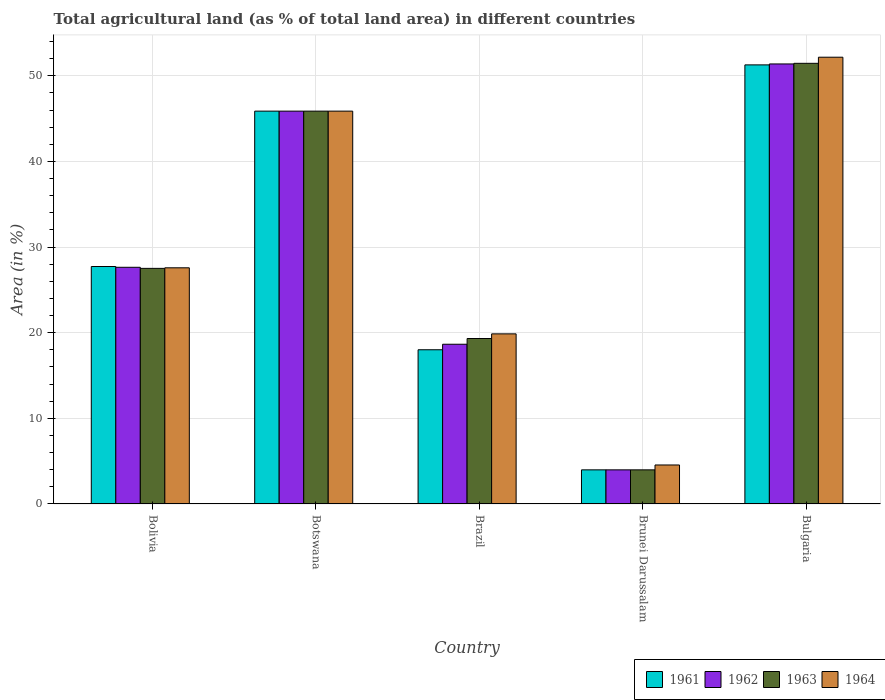How many bars are there on the 2nd tick from the left?
Your answer should be compact. 4. How many bars are there on the 3rd tick from the right?
Your answer should be very brief. 4. What is the label of the 5th group of bars from the left?
Your answer should be compact. Bulgaria. In how many cases, is the number of bars for a given country not equal to the number of legend labels?
Your answer should be compact. 0. What is the percentage of agricultural land in 1963 in Brazil?
Make the answer very short. 19.32. Across all countries, what is the maximum percentage of agricultural land in 1964?
Your response must be concise. 52.17. Across all countries, what is the minimum percentage of agricultural land in 1961?
Ensure brevity in your answer.  3.98. In which country was the percentage of agricultural land in 1961 maximum?
Ensure brevity in your answer.  Bulgaria. In which country was the percentage of agricultural land in 1962 minimum?
Ensure brevity in your answer.  Brunei Darussalam. What is the total percentage of agricultural land in 1961 in the graph?
Make the answer very short. 146.88. What is the difference between the percentage of agricultural land in 1961 in Bolivia and that in Brunei Darussalam?
Provide a short and direct response. 23.75. What is the difference between the percentage of agricultural land in 1962 in Botswana and the percentage of agricultural land in 1963 in Brazil?
Offer a terse response. 26.55. What is the average percentage of agricultural land in 1961 per country?
Your response must be concise. 29.38. What is the difference between the percentage of agricultural land of/in 1962 and percentage of agricultural land of/in 1964 in Brunei Darussalam?
Make the answer very short. -0.57. In how many countries, is the percentage of agricultural land in 1963 greater than 8 %?
Offer a very short reply. 4. What is the ratio of the percentage of agricultural land in 1961 in Botswana to that in Bulgaria?
Make the answer very short. 0.89. What is the difference between the highest and the second highest percentage of agricultural land in 1964?
Give a very brief answer. -24.59. What is the difference between the highest and the lowest percentage of agricultural land in 1964?
Your response must be concise. 47.62. In how many countries, is the percentage of agricultural land in 1962 greater than the average percentage of agricultural land in 1962 taken over all countries?
Your answer should be very brief. 2. What does the 1st bar from the right in Botswana represents?
Your answer should be compact. 1964. How many bars are there?
Give a very brief answer. 20. Are all the bars in the graph horizontal?
Keep it short and to the point. No. Does the graph contain any zero values?
Provide a succinct answer. No. Does the graph contain grids?
Offer a very short reply. Yes. What is the title of the graph?
Keep it short and to the point. Total agricultural land (as % of total land area) in different countries. Does "1984" appear as one of the legend labels in the graph?
Offer a terse response. No. What is the label or title of the X-axis?
Offer a very short reply. Country. What is the label or title of the Y-axis?
Your answer should be compact. Area (in %). What is the Area (in %) in 1961 in Bolivia?
Give a very brief answer. 27.73. What is the Area (in %) of 1962 in Bolivia?
Offer a terse response. 27.64. What is the Area (in %) in 1963 in Bolivia?
Your answer should be very brief. 27.52. What is the Area (in %) in 1964 in Bolivia?
Provide a succinct answer. 27.58. What is the Area (in %) in 1961 in Botswana?
Make the answer very short. 45.88. What is the Area (in %) in 1962 in Botswana?
Your response must be concise. 45.88. What is the Area (in %) of 1963 in Botswana?
Offer a very short reply. 45.88. What is the Area (in %) of 1964 in Botswana?
Provide a short and direct response. 45.88. What is the Area (in %) in 1961 in Brazil?
Offer a terse response. 18.01. What is the Area (in %) in 1962 in Brazil?
Make the answer very short. 18.65. What is the Area (in %) of 1963 in Brazil?
Provide a succinct answer. 19.32. What is the Area (in %) of 1964 in Brazil?
Your answer should be compact. 19.87. What is the Area (in %) of 1961 in Brunei Darussalam?
Provide a short and direct response. 3.98. What is the Area (in %) of 1962 in Brunei Darussalam?
Keep it short and to the point. 3.98. What is the Area (in %) of 1963 in Brunei Darussalam?
Give a very brief answer. 3.98. What is the Area (in %) of 1964 in Brunei Darussalam?
Keep it short and to the point. 4.55. What is the Area (in %) of 1961 in Bulgaria?
Ensure brevity in your answer.  51.28. What is the Area (in %) in 1962 in Bulgaria?
Provide a succinct answer. 51.39. What is the Area (in %) of 1963 in Bulgaria?
Your answer should be compact. 51.46. What is the Area (in %) in 1964 in Bulgaria?
Your answer should be very brief. 52.17. Across all countries, what is the maximum Area (in %) in 1961?
Give a very brief answer. 51.28. Across all countries, what is the maximum Area (in %) of 1962?
Make the answer very short. 51.39. Across all countries, what is the maximum Area (in %) of 1963?
Give a very brief answer. 51.46. Across all countries, what is the maximum Area (in %) in 1964?
Your answer should be very brief. 52.17. Across all countries, what is the minimum Area (in %) of 1961?
Provide a short and direct response. 3.98. Across all countries, what is the minimum Area (in %) in 1962?
Offer a very short reply. 3.98. Across all countries, what is the minimum Area (in %) of 1963?
Give a very brief answer. 3.98. Across all countries, what is the minimum Area (in %) of 1964?
Give a very brief answer. 4.55. What is the total Area (in %) in 1961 in the graph?
Make the answer very short. 146.88. What is the total Area (in %) in 1962 in the graph?
Provide a short and direct response. 147.54. What is the total Area (in %) of 1963 in the graph?
Give a very brief answer. 148.16. What is the total Area (in %) in 1964 in the graph?
Provide a succinct answer. 150.05. What is the difference between the Area (in %) of 1961 in Bolivia and that in Botswana?
Give a very brief answer. -18.15. What is the difference between the Area (in %) in 1962 in Bolivia and that in Botswana?
Provide a succinct answer. -18.24. What is the difference between the Area (in %) in 1963 in Bolivia and that in Botswana?
Provide a short and direct response. -18.36. What is the difference between the Area (in %) of 1964 in Bolivia and that in Botswana?
Offer a terse response. -18.3. What is the difference between the Area (in %) of 1961 in Bolivia and that in Brazil?
Ensure brevity in your answer.  9.72. What is the difference between the Area (in %) of 1962 in Bolivia and that in Brazil?
Provide a succinct answer. 8.99. What is the difference between the Area (in %) of 1963 in Bolivia and that in Brazil?
Provide a succinct answer. 8.19. What is the difference between the Area (in %) of 1964 in Bolivia and that in Brazil?
Ensure brevity in your answer.  7.71. What is the difference between the Area (in %) of 1961 in Bolivia and that in Brunei Darussalam?
Make the answer very short. 23.75. What is the difference between the Area (in %) in 1962 in Bolivia and that in Brunei Darussalam?
Offer a very short reply. 23.65. What is the difference between the Area (in %) of 1963 in Bolivia and that in Brunei Darussalam?
Keep it short and to the point. 23.53. What is the difference between the Area (in %) in 1964 in Bolivia and that in Brunei Darussalam?
Provide a succinct answer. 23.03. What is the difference between the Area (in %) in 1961 in Bolivia and that in Bulgaria?
Your answer should be compact. -23.55. What is the difference between the Area (in %) in 1962 in Bolivia and that in Bulgaria?
Ensure brevity in your answer.  -23.75. What is the difference between the Area (in %) of 1963 in Bolivia and that in Bulgaria?
Give a very brief answer. -23.94. What is the difference between the Area (in %) in 1964 in Bolivia and that in Bulgaria?
Your response must be concise. -24.59. What is the difference between the Area (in %) of 1961 in Botswana and that in Brazil?
Your answer should be very brief. 27.87. What is the difference between the Area (in %) of 1962 in Botswana and that in Brazil?
Your answer should be very brief. 27.22. What is the difference between the Area (in %) in 1963 in Botswana and that in Brazil?
Provide a succinct answer. 26.55. What is the difference between the Area (in %) in 1964 in Botswana and that in Brazil?
Your answer should be compact. 26.01. What is the difference between the Area (in %) of 1961 in Botswana and that in Brunei Darussalam?
Provide a short and direct response. 41.89. What is the difference between the Area (in %) in 1962 in Botswana and that in Brunei Darussalam?
Your answer should be compact. 41.89. What is the difference between the Area (in %) of 1963 in Botswana and that in Brunei Darussalam?
Ensure brevity in your answer.  41.89. What is the difference between the Area (in %) in 1964 in Botswana and that in Brunei Darussalam?
Provide a short and direct response. 41.32. What is the difference between the Area (in %) of 1961 in Botswana and that in Bulgaria?
Give a very brief answer. -5.4. What is the difference between the Area (in %) in 1962 in Botswana and that in Bulgaria?
Your response must be concise. -5.51. What is the difference between the Area (in %) of 1963 in Botswana and that in Bulgaria?
Offer a terse response. -5.58. What is the difference between the Area (in %) in 1964 in Botswana and that in Bulgaria?
Your answer should be very brief. -6.3. What is the difference between the Area (in %) in 1961 in Brazil and that in Brunei Darussalam?
Your answer should be compact. 14.03. What is the difference between the Area (in %) in 1962 in Brazil and that in Brunei Darussalam?
Ensure brevity in your answer.  14.67. What is the difference between the Area (in %) in 1963 in Brazil and that in Brunei Darussalam?
Your answer should be compact. 15.34. What is the difference between the Area (in %) of 1964 in Brazil and that in Brunei Darussalam?
Provide a succinct answer. 15.31. What is the difference between the Area (in %) of 1961 in Brazil and that in Bulgaria?
Ensure brevity in your answer.  -33.27. What is the difference between the Area (in %) of 1962 in Brazil and that in Bulgaria?
Offer a terse response. -32.73. What is the difference between the Area (in %) of 1963 in Brazil and that in Bulgaria?
Offer a very short reply. -32.14. What is the difference between the Area (in %) of 1964 in Brazil and that in Bulgaria?
Keep it short and to the point. -32.31. What is the difference between the Area (in %) in 1961 in Brunei Darussalam and that in Bulgaria?
Keep it short and to the point. -47.29. What is the difference between the Area (in %) of 1962 in Brunei Darussalam and that in Bulgaria?
Your answer should be very brief. -47.4. What is the difference between the Area (in %) in 1963 in Brunei Darussalam and that in Bulgaria?
Provide a succinct answer. -47.48. What is the difference between the Area (in %) of 1964 in Brunei Darussalam and that in Bulgaria?
Provide a succinct answer. -47.62. What is the difference between the Area (in %) of 1961 in Bolivia and the Area (in %) of 1962 in Botswana?
Ensure brevity in your answer.  -18.15. What is the difference between the Area (in %) in 1961 in Bolivia and the Area (in %) in 1963 in Botswana?
Keep it short and to the point. -18.15. What is the difference between the Area (in %) in 1961 in Bolivia and the Area (in %) in 1964 in Botswana?
Offer a very short reply. -18.15. What is the difference between the Area (in %) of 1962 in Bolivia and the Area (in %) of 1963 in Botswana?
Your answer should be compact. -18.24. What is the difference between the Area (in %) of 1962 in Bolivia and the Area (in %) of 1964 in Botswana?
Keep it short and to the point. -18.24. What is the difference between the Area (in %) of 1963 in Bolivia and the Area (in %) of 1964 in Botswana?
Offer a very short reply. -18.36. What is the difference between the Area (in %) in 1961 in Bolivia and the Area (in %) in 1962 in Brazil?
Your answer should be compact. 9.08. What is the difference between the Area (in %) of 1961 in Bolivia and the Area (in %) of 1963 in Brazil?
Give a very brief answer. 8.41. What is the difference between the Area (in %) in 1961 in Bolivia and the Area (in %) in 1964 in Brazil?
Your answer should be very brief. 7.87. What is the difference between the Area (in %) in 1962 in Bolivia and the Area (in %) in 1963 in Brazil?
Offer a very short reply. 8.32. What is the difference between the Area (in %) of 1962 in Bolivia and the Area (in %) of 1964 in Brazil?
Your response must be concise. 7.77. What is the difference between the Area (in %) in 1963 in Bolivia and the Area (in %) in 1964 in Brazil?
Offer a terse response. 7.65. What is the difference between the Area (in %) in 1961 in Bolivia and the Area (in %) in 1962 in Brunei Darussalam?
Provide a short and direct response. 23.75. What is the difference between the Area (in %) of 1961 in Bolivia and the Area (in %) of 1963 in Brunei Darussalam?
Provide a short and direct response. 23.75. What is the difference between the Area (in %) of 1961 in Bolivia and the Area (in %) of 1964 in Brunei Darussalam?
Ensure brevity in your answer.  23.18. What is the difference between the Area (in %) of 1962 in Bolivia and the Area (in %) of 1963 in Brunei Darussalam?
Your answer should be compact. 23.65. What is the difference between the Area (in %) of 1962 in Bolivia and the Area (in %) of 1964 in Brunei Darussalam?
Ensure brevity in your answer.  23.09. What is the difference between the Area (in %) of 1963 in Bolivia and the Area (in %) of 1964 in Brunei Darussalam?
Keep it short and to the point. 22.96. What is the difference between the Area (in %) in 1961 in Bolivia and the Area (in %) in 1962 in Bulgaria?
Make the answer very short. -23.66. What is the difference between the Area (in %) of 1961 in Bolivia and the Area (in %) of 1963 in Bulgaria?
Make the answer very short. -23.73. What is the difference between the Area (in %) in 1961 in Bolivia and the Area (in %) in 1964 in Bulgaria?
Your response must be concise. -24.44. What is the difference between the Area (in %) in 1962 in Bolivia and the Area (in %) in 1963 in Bulgaria?
Make the answer very short. -23.82. What is the difference between the Area (in %) of 1962 in Bolivia and the Area (in %) of 1964 in Bulgaria?
Your response must be concise. -24.53. What is the difference between the Area (in %) of 1963 in Bolivia and the Area (in %) of 1964 in Bulgaria?
Provide a short and direct response. -24.66. What is the difference between the Area (in %) of 1961 in Botswana and the Area (in %) of 1962 in Brazil?
Offer a very short reply. 27.22. What is the difference between the Area (in %) in 1961 in Botswana and the Area (in %) in 1963 in Brazil?
Offer a terse response. 26.55. What is the difference between the Area (in %) in 1961 in Botswana and the Area (in %) in 1964 in Brazil?
Provide a succinct answer. 26.01. What is the difference between the Area (in %) of 1962 in Botswana and the Area (in %) of 1963 in Brazil?
Your answer should be compact. 26.55. What is the difference between the Area (in %) in 1962 in Botswana and the Area (in %) in 1964 in Brazil?
Make the answer very short. 26.01. What is the difference between the Area (in %) of 1963 in Botswana and the Area (in %) of 1964 in Brazil?
Your response must be concise. 26.01. What is the difference between the Area (in %) in 1961 in Botswana and the Area (in %) in 1962 in Brunei Darussalam?
Ensure brevity in your answer.  41.89. What is the difference between the Area (in %) of 1961 in Botswana and the Area (in %) of 1963 in Brunei Darussalam?
Offer a terse response. 41.89. What is the difference between the Area (in %) in 1961 in Botswana and the Area (in %) in 1964 in Brunei Darussalam?
Make the answer very short. 41.32. What is the difference between the Area (in %) in 1962 in Botswana and the Area (in %) in 1963 in Brunei Darussalam?
Give a very brief answer. 41.89. What is the difference between the Area (in %) of 1962 in Botswana and the Area (in %) of 1964 in Brunei Darussalam?
Your answer should be very brief. 41.32. What is the difference between the Area (in %) of 1963 in Botswana and the Area (in %) of 1964 in Brunei Darussalam?
Your answer should be compact. 41.32. What is the difference between the Area (in %) in 1961 in Botswana and the Area (in %) in 1962 in Bulgaria?
Your answer should be very brief. -5.51. What is the difference between the Area (in %) in 1961 in Botswana and the Area (in %) in 1963 in Bulgaria?
Your answer should be very brief. -5.58. What is the difference between the Area (in %) in 1961 in Botswana and the Area (in %) in 1964 in Bulgaria?
Give a very brief answer. -6.3. What is the difference between the Area (in %) of 1962 in Botswana and the Area (in %) of 1963 in Bulgaria?
Provide a succinct answer. -5.58. What is the difference between the Area (in %) in 1962 in Botswana and the Area (in %) in 1964 in Bulgaria?
Give a very brief answer. -6.3. What is the difference between the Area (in %) of 1963 in Botswana and the Area (in %) of 1964 in Bulgaria?
Your answer should be compact. -6.3. What is the difference between the Area (in %) in 1961 in Brazil and the Area (in %) in 1962 in Brunei Darussalam?
Your response must be concise. 14.03. What is the difference between the Area (in %) of 1961 in Brazil and the Area (in %) of 1963 in Brunei Darussalam?
Keep it short and to the point. 14.03. What is the difference between the Area (in %) in 1961 in Brazil and the Area (in %) in 1964 in Brunei Darussalam?
Offer a terse response. 13.46. What is the difference between the Area (in %) in 1962 in Brazil and the Area (in %) in 1963 in Brunei Darussalam?
Your response must be concise. 14.67. What is the difference between the Area (in %) in 1962 in Brazil and the Area (in %) in 1964 in Brunei Darussalam?
Provide a short and direct response. 14.1. What is the difference between the Area (in %) of 1963 in Brazil and the Area (in %) of 1964 in Brunei Darussalam?
Ensure brevity in your answer.  14.77. What is the difference between the Area (in %) of 1961 in Brazil and the Area (in %) of 1962 in Bulgaria?
Your answer should be very brief. -33.38. What is the difference between the Area (in %) of 1961 in Brazil and the Area (in %) of 1963 in Bulgaria?
Your response must be concise. -33.45. What is the difference between the Area (in %) in 1961 in Brazil and the Area (in %) in 1964 in Bulgaria?
Ensure brevity in your answer.  -34.16. What is the difference between the Area (in %) of 1962 in Brazil and the Area (in %) of 1963 in Bulgaria?
Provide a succinct answer. -32.81. What is the difference between the Area (in %) of 1962 in Brazil and the Area (in %) of 1964 in Bulgaria?
Your answer should be compact. -33.52. What is the difference between the Area (in %) in 1963 in Brazil and the Area (in %) in 1964 in Bulgaria?
Offer a terse response. -32.85. What is the difference between the Area (in %) in 1961 in Brunei Darussalam and the Area (in %) in 1962 in Bulgaria?
Keep it short and to the point. -47.4. What is the difference between the Area (in %) in 1961 in Brunei Darussalam and the Area (in %) in 1963 in Bulgaria?
Make the answer very short. -47.48. What is the difference between the Area (in %) of 1961 in Brunei Darussalam and the Area (in %) of 1964 in Bulgaria?
Your answer should be compact. -48.19. What is the difference between the Area (in %) of 1962 in Brunei Darussalam and the Area (in %) of 1963 in Bulgaria?
Offer a terse response. -47.48. What is the difference between the Area (in %) of 1962 in Brunei Darussalam and the Area (in %) of 1964 in Bulgaria?
Keep it short and to the point. -48.19. What is the difference between the Area (in %) of 1963 in Brunei Darussalam and the Area (in %) of 1964 in Bulgaria?
Provide a succinct answer. -48.19. What is the average Area (in %) in 1961 per country?
Offer a terse response. 29.38. What is the average Area (in %) in 1962 per country?
Give a very brief answer. 29.51. What is the average Area (in %) in 1963 per country?
Provide a succinct answer. 29.63. What is the average Area (in %) of 1964 per country?
Offer a very short reply. 30.01. What is the difference between the Area (in %) of 1961 and Area (in %) of 1962 in Bolivia?
Your answer should be compact. 0.09. What is the difference between the Area (in %) of 1961 and Area (in %) of 1963 in Bolivia?
Ensure brevity in your answer.  0.22. What is the difference between the Area (in %) of 1961 and Area (in %) of 1964 in Bolivia?
Make the answer very short. 0.15. What is the difference between the Area (in %) in 1962 and Area (in %) in 1963 in Bolivia?
Your answer should be compact. 0.12. What is the difference between the Area (in %) in 1962 and Area (in %) in 1964 in Bolivia?
Make the answer very short. 0.06. What is the difference between the Area (in %) of 1963 and Area (in %) of 1964 in Bolivia?
Your answer should be compact. -0.07. What is the difference between the Area (in %) of 1961 and Area (in %) of 1963 in Botswana?
Ensure brevity in your answer.  0. What is the difference between the Area (in %) in 1962 and Area (in %) in 1963 in Botswana?
Keep it short and to the point. 0. What is the difference between the Area (in %) in 1961 and Area (in %) in 1962 in Brazil?
Offer a terse response. -0.64. What is the difference between the Area (in %) of 1961 and Area (in %) of 1963 in Brazil?
Ensure brevity in your answer.  -1.31. What is the difference between the Area (in %) in 1961 and Area (in %) in 1964 in Brazil?
Ensure brevity in your answer.  -1.86. What is the difference between the Area (in %) in 1962 and Area (in %) in 1963 in Brazil?
Your answer should be compact. -0.67. What is the difference between the Area (in %) of 1962 and Area (in %) of 1964 in Brazil?
Your answer should be very brief. -1.21. What is the difference between the Area (in %) in 1963 and Area (in %) in 1964 in Brazil?
Ensure brevity in your answer.  -0.54. What is the difference between the Area (in %) in 1961 and Area (in %) in 1964 in Brunei Darussalam?
Offer a terse response. -0.57. What is the difference between the Area (in %) in 1962 and Area (in %) in 1963 in Brunei Darussalam?
Provide a succinct answer. 0. What is the difference between the Area (in %) in 1962 and Area (in %) in 1964 in Brunei Darussalam?
Keep it short and to the point. -0.57. What is the difference between the Area (in %) in 1963 and Area (in %) in 1964 in Brunei Darussalam?
Make the answer very short. -0.57. What is the difference between the Area (in %) of 1961 and Area (in %) of 1962 in Bulgaria?
Your response must be concise. -0.11. What is the difference between the Area (in %) in 1961 and Area (in %) in 1963 in Bulgaria?
Your answer should be very brief. -0.18. What is the difference between the Area (in %) in 1961 and Area (in %) in 1964 in Bulgaria?
Keep it short and to the point. -0.89. What is the difference between the Area (in %) of 1962 and Area (in %) of 1963 in Bulgaria?
Your answer should be compact. -0.07. What is the difference between the Area (in %) in 1962 and Area (in %) in 1964 in Bulgaria?
Provide a short and direct response. -0.79. What is the difference between the Area (in %) in 1963 and Area (in %) in 1964 in Bulgaria?
Make the answer very short. -0.71. What is the ratio of the Area (in %) of 1961 in Bolivia to that in Botswana?
Keep it short and to the point. 0.6. What is the ratio of the Area (in %) of 1962 in Bolivia to that in Botswana?
Offer a terse response. 0.6. What is the ratio of the Area (in %) in 1963 in Bolivia to that in Botswana?
Make the answer very short. 0.6. What is the ratio of the Area (in %) in 1964 in Bolivia to that in Botswana?
Offer a very short reply. 0.6. What is the ratio of the Area (in %) in 1961 in Bolivia to that in Brazil?
Make the answer very short. 1.54. What is the ratio of the Area (in %) of 1962 in Bolivia to that in Brazil?
Offer a terse response. 1.48. What is the ratio of the Area (in %) in 1963 in Bolivia to that in Brazil?
Offer a very short reply. 1.42. What is the ratio of the Area (in %) in 1964 in Bolivia to that in Brazil?
Your answer should be compact. 1.39. What is the ratio of the Area (in %) in 1961 in Bolivia to that in Brunei Darussalam?
Provide a short and direct response. 6.96. What is the ratio of the Area (in %) of 1962 in Bolivia to that in Brunei Darussalam?
Offer a very short reply. 6.94. What is the ratio of the Area (in %) of 1963 in Bolivia to that in Brunei Darussalam?
Provide a short and direct response. 6.91. What is the ratio of the Area (in %) of 1964 in Bolivia to that in Brunei Darussalam?
Ensure brevity in your answer.  6.06. What is the ratio of the Area (in %) in 1961 in Bolivia to that in Bulgaria?
Your response must be concise. 0.54. What is the ratio of the Area (in %) of 1962 in Bolivia to that in Bulgaria?
Offer a terse response. 0.54. What is the ratio of the Area (in %) of 1963 in Bolivia to that in Bulgaria?
Keep it short and to the point. 0.53. What is the ratio of the Area (in %) in 1964 in Bolivia to that in Bulgaria?
Make the answer very short. 0.53. What is the ratio of the Area (in %) of 1961 in Botswana to that in Brazil?
Offer a very short reply. 2.55. What is the ratio of the Area (in %) of 1962 in Botswana to that in Brazil?
Your response must be concise. 2.46. What is the ratio of the Area (in %) of 1963 in Botswana to that in Brazil?
Your answer should be compact. 2.37. What is the ratio of the Area (in %) of 1964 in Botswana to that in Brazil?
Provide a succinct answer. 2.31. What is the ratio of the Area (in %) in 1961 in Botswana to that in Brunei Darussalam?
Ensure brevity in your answer.  11.51. What is the ratio of the Area (in %) in 1962 in Botswana to that in Brunei Darussalam?
Provide a short and direct response. 11.51. What is the ratio of the Area (in %) of 1963 in Botswana to that in Brunei Darussalam?
Keep it short and to the point. 11.51. What is the ratio of the Area (in %) in 1964 in Botswana to that in Brunei Darussalam?
Give a very brief answer. 10.07. What is the ratio of the Area (in %) in 1961 in Botswana to that in Bulgaria?
Offer a terse response. 0.89. What is the ratio of the Area (in %) in 1962 in Botswana to that in Bulgaria?
Your answer should be very brief. 0.89. What is the ratio of the Area (in %) in 1963 in Botswana to that in Bulgaria?
Offer a terse response. 0.89. What is the ratio of the Area (in %) in 1964 in Botswana to that in Bulgaria?
Ensure brevity in your answer.  0.88. What is the ratio of the Area (in %) in 1961 in Brazil to that in Brunei Darussalam?
Keep it short and to the point. 4.52. What is the ratio of the Area (in %) in 1962 in Brazil to that in Brunei Darussalam?
Your response must be concise. 4.68. What is the ratio of the Area (in %) in 1963 in Brazil to that in Brunei Darussalam?
Your answer should be compact. 4.85. What is the ratio of the Area (in %) in 1964 in Brazil to that in Brunei Darussalam?
Offer a very short reply. 4.36. What is the ratio of the Area (in %) in 1961 in Brazil to that in Bulgaria?
Give a very brief answer. 0.35. What is the ratio of the Area (in %) in 1962 in Brazil to that in Bulgaria?
Provide a short and direct response. 0.36. What is the ratio of the Area (in %) of 1963 in Brazil to that in Bulgaria?
Provide a succinct answer. 0.38. What is the ratio of the Area (in %) in 1964 in Brazil to that in Bulgaria?
Your answer should be very brief. 0.38. What is the ratio of the Area (in %) of 1961 in Brunei Darussalam to that in Bulgaria?
Offer a very short reply. 0.08. What is the ratio of the Area (in %) in 1962 in Brunei Darussalam to that in Bulgaria?
Give a very brief answer. 0.08. What is the ratio of the Area (in %) in 1963 in Brunei Darussalam to that in Bulgaria?
Provide a succinct answer. 0.08. What is the ratio of the Area (in %) of 1964 in Brunei Darussalam to that in Bulgaria?
Provide a short and direct response. 0.09. What is the difference between the highest and the second highest Area (in %) in 1961?
Keep it short and to the point. 5.4. What is the difference between the highest and the second highest Area (in %) of 1962?
Give a very brief answer. 5.51. What is the difference between the highest and the second highest Area (in %) of 1963?
Provide a succinct answer. 5.58. What is the difference between the highest and the second highest Area (in %) in 1964?
Provide a short and direct response. 6.3. What is the difference between the highest and the lowest Area (in %) in 1961?
Offer a terse response. 47.29. What is the difference between the highest and the lowest Area (in %) of 1962?
Keep it short and to the point. 47.4. What is the difference between the highest and the lowest Area (in %) of 1963?
Ensure brevity in your answer.  47.48. What is the difference between the highest and the lowest Area (in %) in 1964?
Your response must be concise. 47.62. 